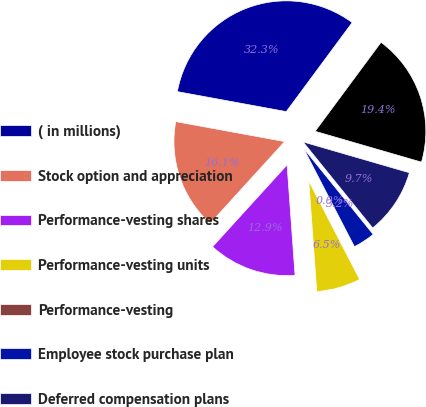Convert chart. <chart><loc_0><loc_0><loc_500><loc_500><pie_chart><fcel>( in millions)<fcel>Stock option and appreciation<fcel>Performance-vesting shares<fcel>Performance-vesting units<fcel>Performance-vesting<fcel>Employee stock purchase plan<fcel>Deferred compensation plans<fcel>Total stock-based compensation<nl><fcel>32.25%<fcel>16.13%<fcel>12.9%<fcel>6.45%<fcel>0.0%<fcel>3.23%<fcel>9.68%<fcel>19.35%<nl></chart> 